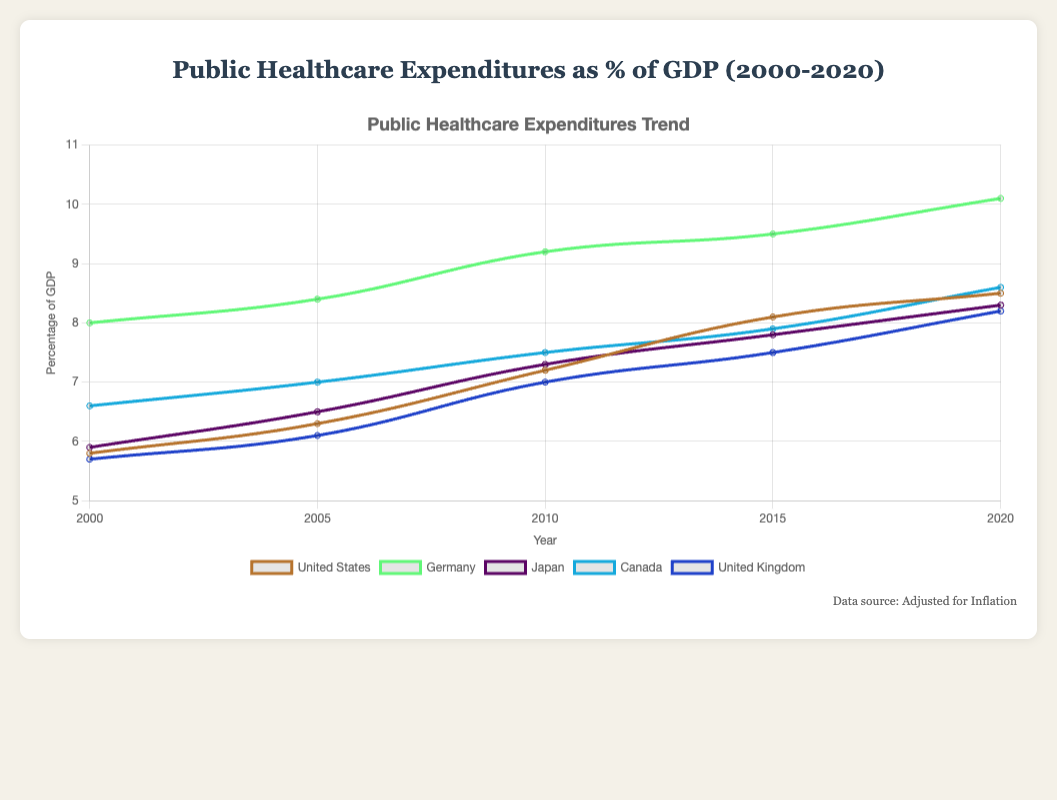What trend can be observed for the United States from 2000 to 2020? The public healthcare expenditures as a percentage of GDP in the United States steadily increased from 5.8% in 2000 to 8.5% in 2020.
Answer: Steady increase Which country had the highest public healthcare expenditure as a percentage of GDP in 2020? In 2020, Germany had the highest public healthcare expenditure as a percentage of GDP at 10.1%. This can be seen by comparing the values for all countries in 2020.
Answer: Germany By how much did Canada's public healthcare expenditure as a percentage of GDP increase from 2000 to 2020? Canada's public healthcare expenditure as a percentage of GDP was 6.6% in 2000 and 8.6% in 2020. The increase is calculated by subtracting the 2000 value from the 2020 value: 8.6% - 6.6% = 2.0%.
Answer: 2.0% Which country had a smaller increase in public healthcare expenditure as a percentage of GDP from 2000 to 2020, Japan or the United Kingdom? Japan's expenditure increased from 5.9% in 2000 to 8.3% in 2020, an increase of 2.4%. The United Kingdom's expenditure increased from 5.7% in 2000 to 8.2% in 2020, an increase of 2.5%. Therefore, Japan had a smaller increase.
Answer: Japan What was the average public healthcare expenditure as a percentage of GDP for Germany from 2000 to 2020? The expenditure values for Germany from 2000 to 2020 are 8.0, 8.4, 9.2, 9.5, and 10.1. The average is calculated by summing these values and dividing by the number of data points: (8.0 + 8.4 + 9.2 + 9.5 + 10.1) / 5 = 45.2 / 5 = 9.04.
Answer: 9.04% Between which years did the United States see the largest increase in public healthcare expenditure as a percentage of GDP? The increases are: 2000 to 2005 (6.3 - 5.8 = 0.5), 2005 to 2010 (7.2 - 6.3 = 0.9), 2010 to 2015 (8.1 - 7.2 = 0.9), 2015 to 2020 (8.5 - 8.1 = 0.4). The largest increase occurred from 2005 to 2010 (0.9%).
Answer: 2005 to 2010 Which country had a steeper increase in public healthcare expenditures as a percentage of GDP, Canada or the United Kingdom, from 2010 to 2020? Canada's expenditure increased from 7.5% to 8.6% (1.1%), and the United Kingdom's from 7.0% to 8.2% (1.2%). The United Kingdom had a steeper increase.
Answer: United Kingdom In which year did Japan's public healthcare expenses surpass 7% of GDP? Japan's public healthcare expenditure surpassed 7% in 2010, as it reached 7.3% that year.
Answer: 2010 